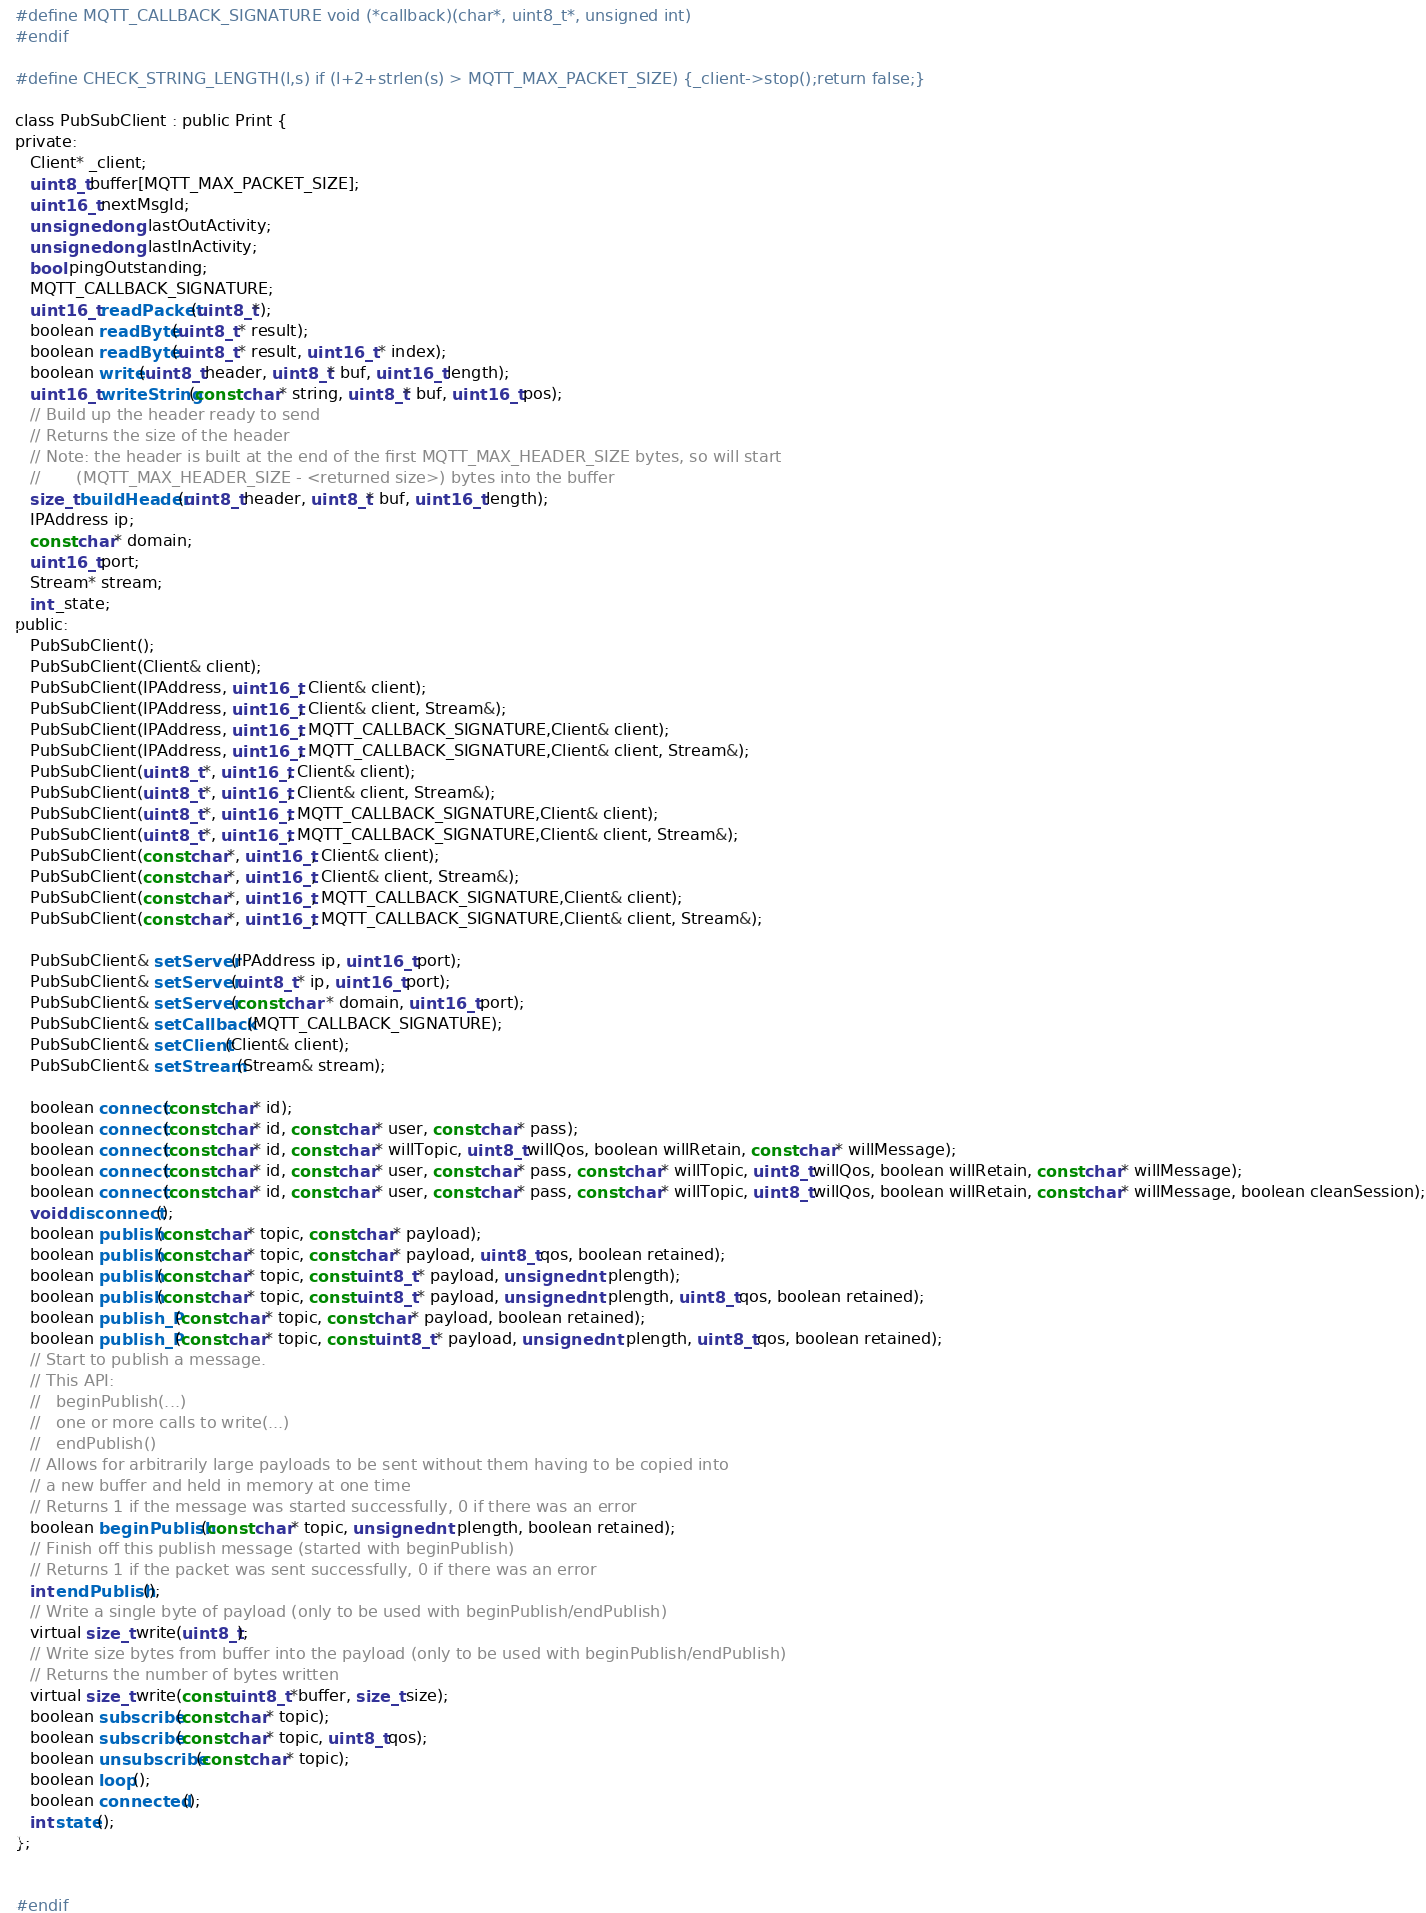Convert code to text. <code><loc_0><loc_0><loc_500><loc_500><_C_>#define MQTT_CALLBACK_SIGNATURE void (*callback)(char*, uint8_t*, unsigned int)
#endif

#define CHECK_STRING_LENGTH(l,s) if (l+2+strlen(s) > MQTT_MAX_PACKET_SIZE) {_client->stop();return false;}

class PubSubClient : public Print {
private:
   Client* _client;
   uint8_t buffer[MQTT_MAX_PACKET_SIZE];
   uint16_t nextMsgId;
   unsigned long lastOutActivity;
   unsigned long lastInActivity;
   bool pingOutstanding;
   MQTT_CALLBACK_SIGNATURE;
   uint16_t readPacket(uint8_t*);
   boolean readByte(uint8_t * result);
   boolean readByte(uint8_t * result, uint16_t * index);
   boolean write(uint8_t header, uint8_t* buf, uint16_t length);
   uint16_t writeString(const char* string, uint8_t* buf, uint16_t pos);
   // Build up the header ready to send
   // Returns the size of the header
   // Note: the header is built at the end of the first MQTT_MAX_HEADER_SIZE bytes, so will start
   //       (MQTT_MAX_HEADER_SIZE - <returned size>) bytes into the buffer
   size_t buildHeader(uint8_t header, uint8_t* buf, uint16_t length);
   IPAddress ip;
   const char* domain;
   uint16_t port;
   Stream* stream;
   int _state;
public:
   PubSubClient();
   PubSubClient(Client& client);
   PubSubClient(IPAddress, uint16_t, Client& client);
   PubSubClient(IPAddress, uint16_t, Client& client, Stream&);
   PubSubClient(IPAddress, uint16_t, MQTT_CALLBACK_SIGNATURE,Client& client);
   PubSubClient(IPAddress, uint16_t, MQTT_CALLBACK_SIGNATURE,Client& client, Stream&);
   PubSubClient(uint8_t *, uint16_t, Client& client);
   PubSubClient(uint8_t *, uint16_t, Client& client, Stream&);
   PubSubClient(uint8_t *, uint16_t, MQTT_CALLBACK_SIGNATURE,Client& client);
   PubSubClient(uint8_t *, uint16_t, MQTT_CALLBACK_SIGNATURE,Client& client, Stream&);
   PubSubClient(const char*, uint16_t, Client& client);
   PubSubClient(const char*, uint16_t, Client& client, Stream&);
   PubSubClient(const char*, uint16_t, MQTT_CALLBACK_SIGNATURE,Client& client);
   PubSubClient(const char*, uint16_t, MQTT_CALLBACK_SIGNATURE,Client& client, Stream&);

   PubSubClient& setServer(IPAddress ip, uint16_t port);
   PubSubClient& setServer(uint8_t * ip, uint16_t port);
   PubSubClient& setServer(const char * domain, uint16_t port);
   PubSubClient& setCallback(MQTT_CALLBACK_SIGNATURE);
   PubSubClient& setClient(Client& client);
   PubSubClient& setStream(Stream& stream);

   boolean connect(const char* id);
   boolean connect(const char* id, const char* user, const char* pass);
   boolean connect(const char* id, const char* willTopic, uint8_t willQos, boolean willRetain, const char* willMessage);
   boolean connect(const char* id, const char* user, const char* pass, const char* willTopic, uint8_t willQos, boolean willRetain, const char* willMessage);
   boolean connect(const char* id, const char* user, const char* pass, const char* willTopic, uint8_t willQos, boolean willRetain, const char* willMessage, boolean cleanSession);
   void disconnect();
   boolean publish(const char* topic, const char* payload);
   boolean publish(const char* topic, const char* payload, uint8_t qos, boolean retained);
   boolean publish(const char* topic, const uint8_t * payload, unsigned int plength);
   boolean publish(const char* topic, const uint8_t * payload, unsigned int plength, uint8_t qos, boolean retained);
   boolean publish_P(const char* topic, const char* payload, boolean retained);
   boolean publish_P(const char* topic, const uint8_t * payload, unsigned int plength, uint8_t qos, boolean retained);
   // Start to publish a message.
   // This API:
   //   beginPublish(...)
   //   one or more calls to write(...)
   //   endPublish()
   // Allows for arbitrarily large payloads to be sent without them having to be copied into
   // a new buffer and held in memory at one time
   // Returns 1 if the message was started successfully, 0 if there was an error
   boolean beginPublish(const char* topic, unsigned int plength, boolean retained);
   // Finish off this publish message (started with beginPublish)
   // Returns 1 if the packet was sent successfully, 0 if there was an error
   int endPublish();
   // Write a single byte of payload (only to be used with beginPublish/endPublish)
   virtual size_t write(uint8_t);
   // Write size bytes from buffer into the payload (only to be used with beginPublish/endPublish)
   // Returns the number of bytes written
   virtual size_t write(const uint8_t *buffer, size_t size);
   boolean subscribe(const char* topic);
   boolean subscribe(const char* topic, uint8_t qos);
   boolean unsubscribe(const char* topic);
   boolean loop();
   boolean connected();
   int state();
};


#endif
</code> 